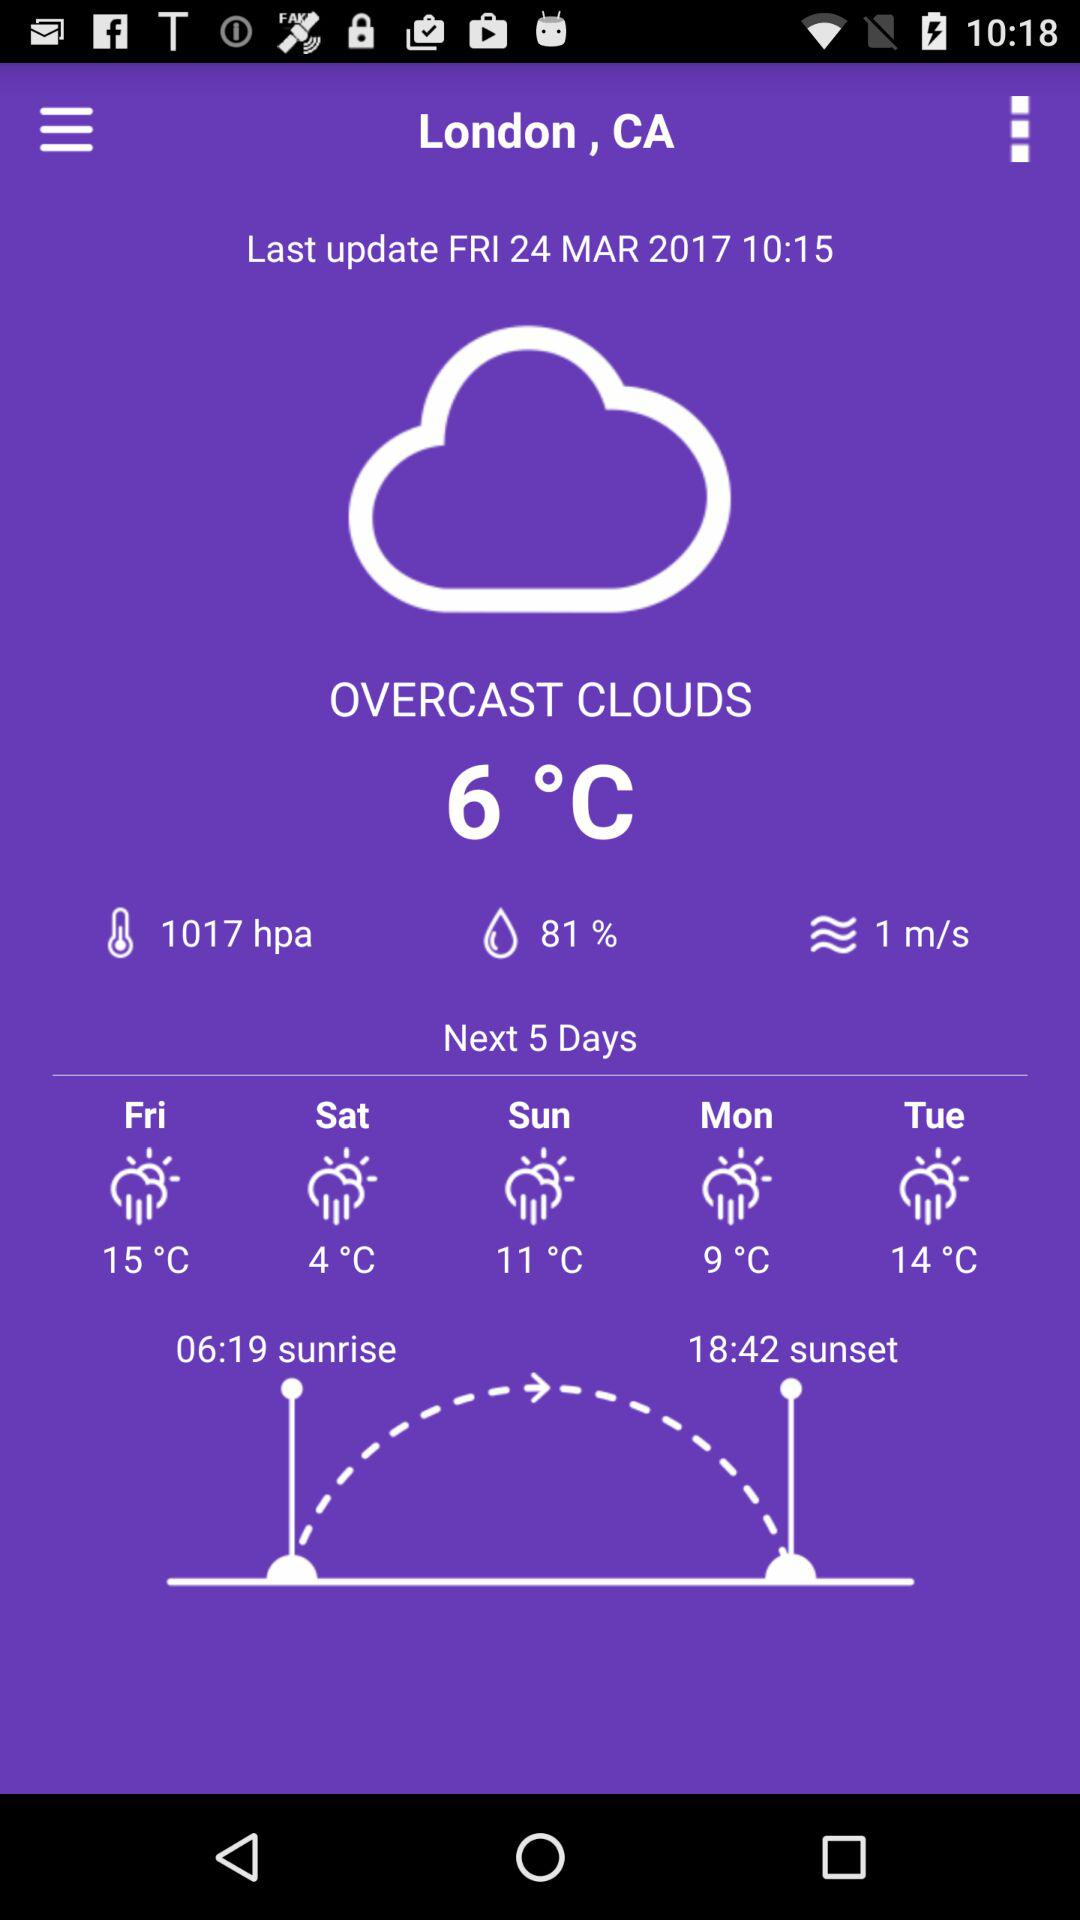What is the sunset time? The sunset time is 18:42. 